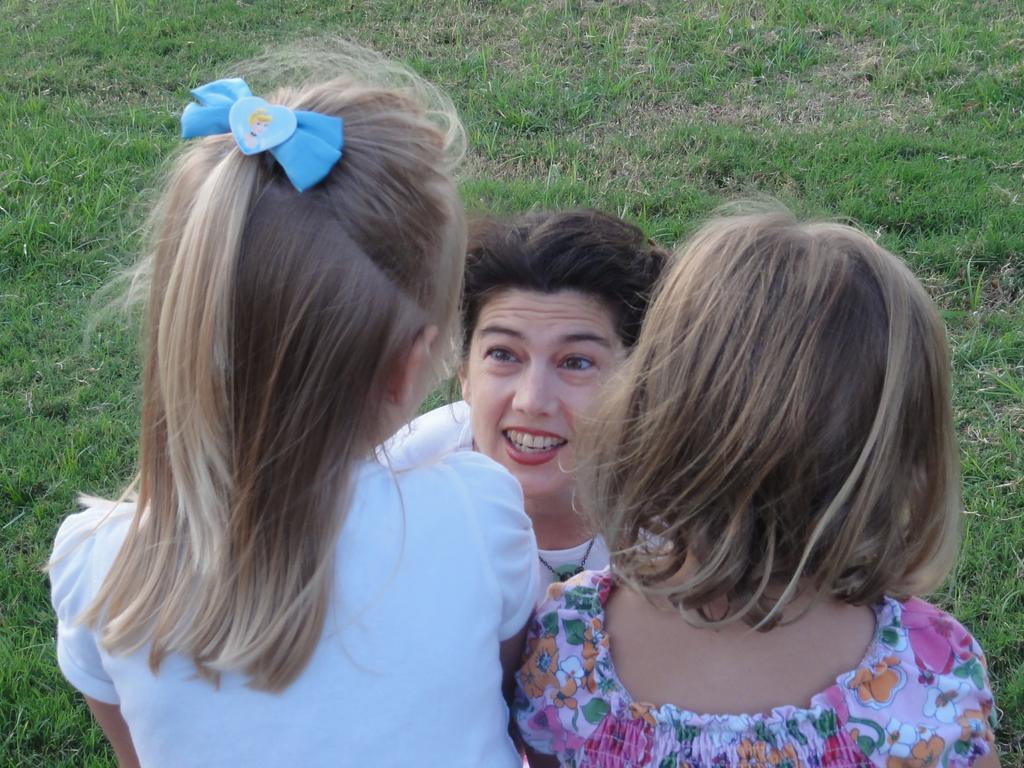How would you summarize this image in a sentence or two? In the picture we can see two girls and one woman sitting on the grass surface, and two girls are standing, one girl is with white T-shirt and one girl is with flower paintings designs T-shirt and a woman is wearing a white T-shirt. 